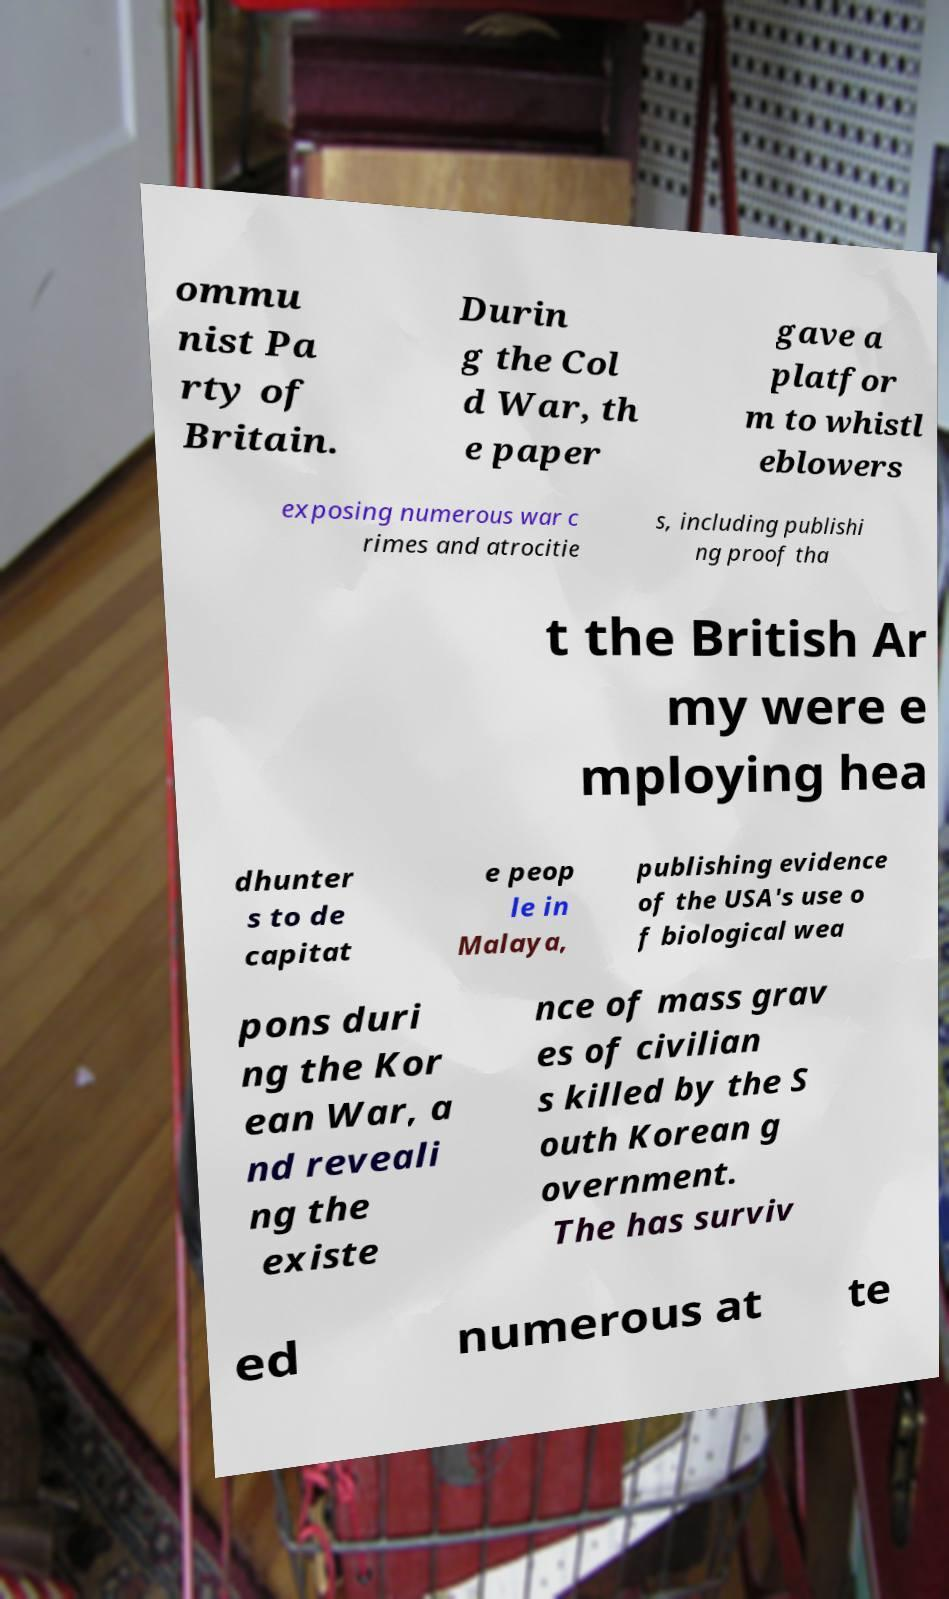Please read and relay the text visible in this image. What does it say? ommu nist Pa rty of Britain. Durin g the Col d War, th e paper gave a platfor m to whistl eblowers exposing numerous war c rimes and atrocitie s, including publishi ng proof tha t the British Ar my were e mploying hea dhunter s to de capitat e peop le in Malaya, publishing evidence of the USA's use o f biological wea pons duri ng the Kor ean War, a nd reveali ng the existe nce of mass grav es of civilian s killed by the S outh Korean g overnment. The has surviv ed numerous at te 